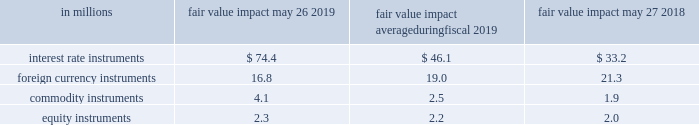The table below presents the estimated maximum potential var arising from a one-day loss in fair value for our interest rate , foreign currency , commodity , and equity market-risk-sensitive instruments outstanding as of may 26 , 2019 and may 27 , 2018 , and the average fair value impact during the year ended may 26 , 2019. .

What is the change in fair value of foreign currency instruments from 2018 to 2019? 
Computations: (16.8 - 21.3)
Answer: -4.5. 